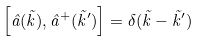<formula> <loc_0><loc_0><loc_500><loc_500>\left [ \hat { a } ( \vec { k } ) , \hat { a } ^ { + } ( \vec { k } ^ { \prime } ) \right ] = \delta ( \vec { k } - \vec { k } ^ { \prime } )</formula> 